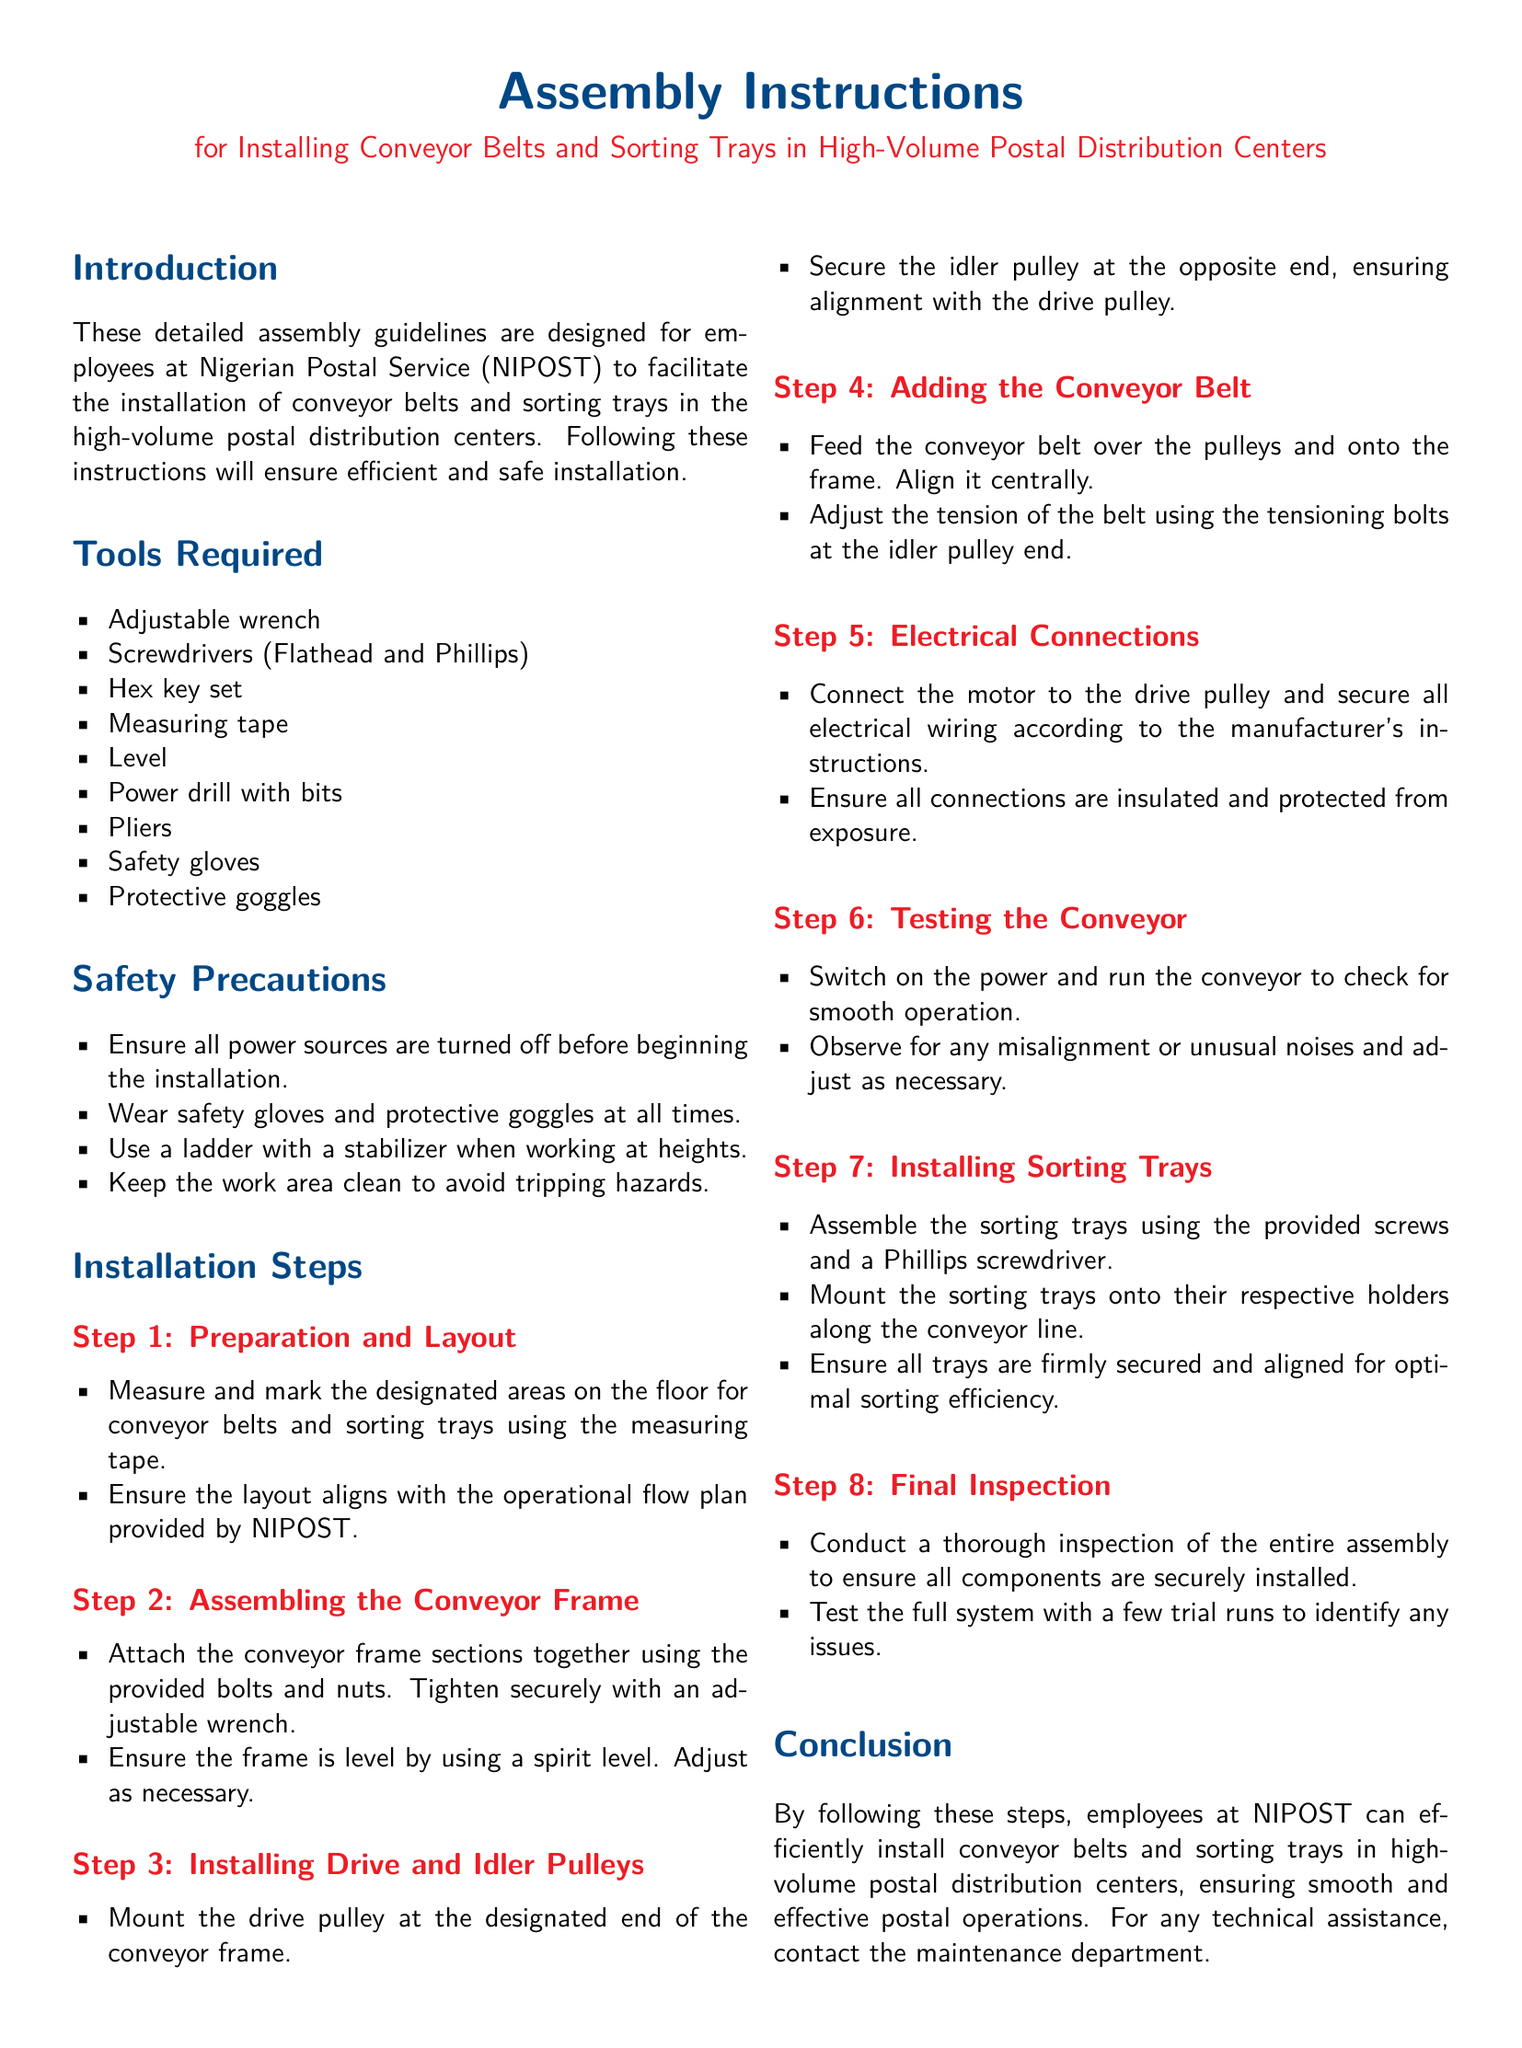What is the document about? The document provides detailed assembly guidelines for installing conveyor belts and sorting trays in high-volume postal distribution centers.
Answer: Assembly Instructions What is the first tool listed? The first tool listed for installation is mentioned in the 'Tools Required' section.
Answer: Adjustable wrench How many steps are outlined in the installation process? The installation process includes a total of eight steps as specified in the 'Installation Steps' section.
Answer: Eight What should be used to ensure the frame is level? The document states that a spirit level should be used to ensure the frame is level.
Answer: Spirit level What is the purpose of the safety gloves? The use of safety gloves is mentioned under 'Safety Precautions' for protection.
Answer: Protection What should be tested after installing the conveyor? The document indicates that the whole system should be tested with a few trial runs to identify issues.
Answer: Whole system How are the sorting trays secured? The sorting trays are secured using provided screws and a Phillips screwdriver during installation.
Answer: Provided screws Who should be contacted for technical assistance? The document mentions contacting the maintenance department for any technical assistance needed post-installation.
Answer: Maintenance department 